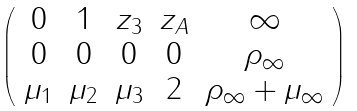<formula> <loc_0><loc_0><loc_500><loc_500>\left ( \begin{array} { c c c c c } { 0 } & { 1 } & { { z _ { 3 } } } & { { z _ { A } } } & { \infty } \\ { 0 } & { 0 } & { 0 } & { 0 } & { { \rho _ { \infty } } } \\ { { \mu _ { 1 } } } & { { \mu _ { 2 } } } & { { \mu _ { 3 } } } & { 2 } & { { \rho _ { \infty } + \mu _ { \infty } } } \end{array} \right )</formula> 